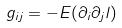<formula> <loc_0><loc_0><loc_500><loc_500>g _ { i j } = - E ( \partial _ { i } \partial _ { j } l )</formula> 